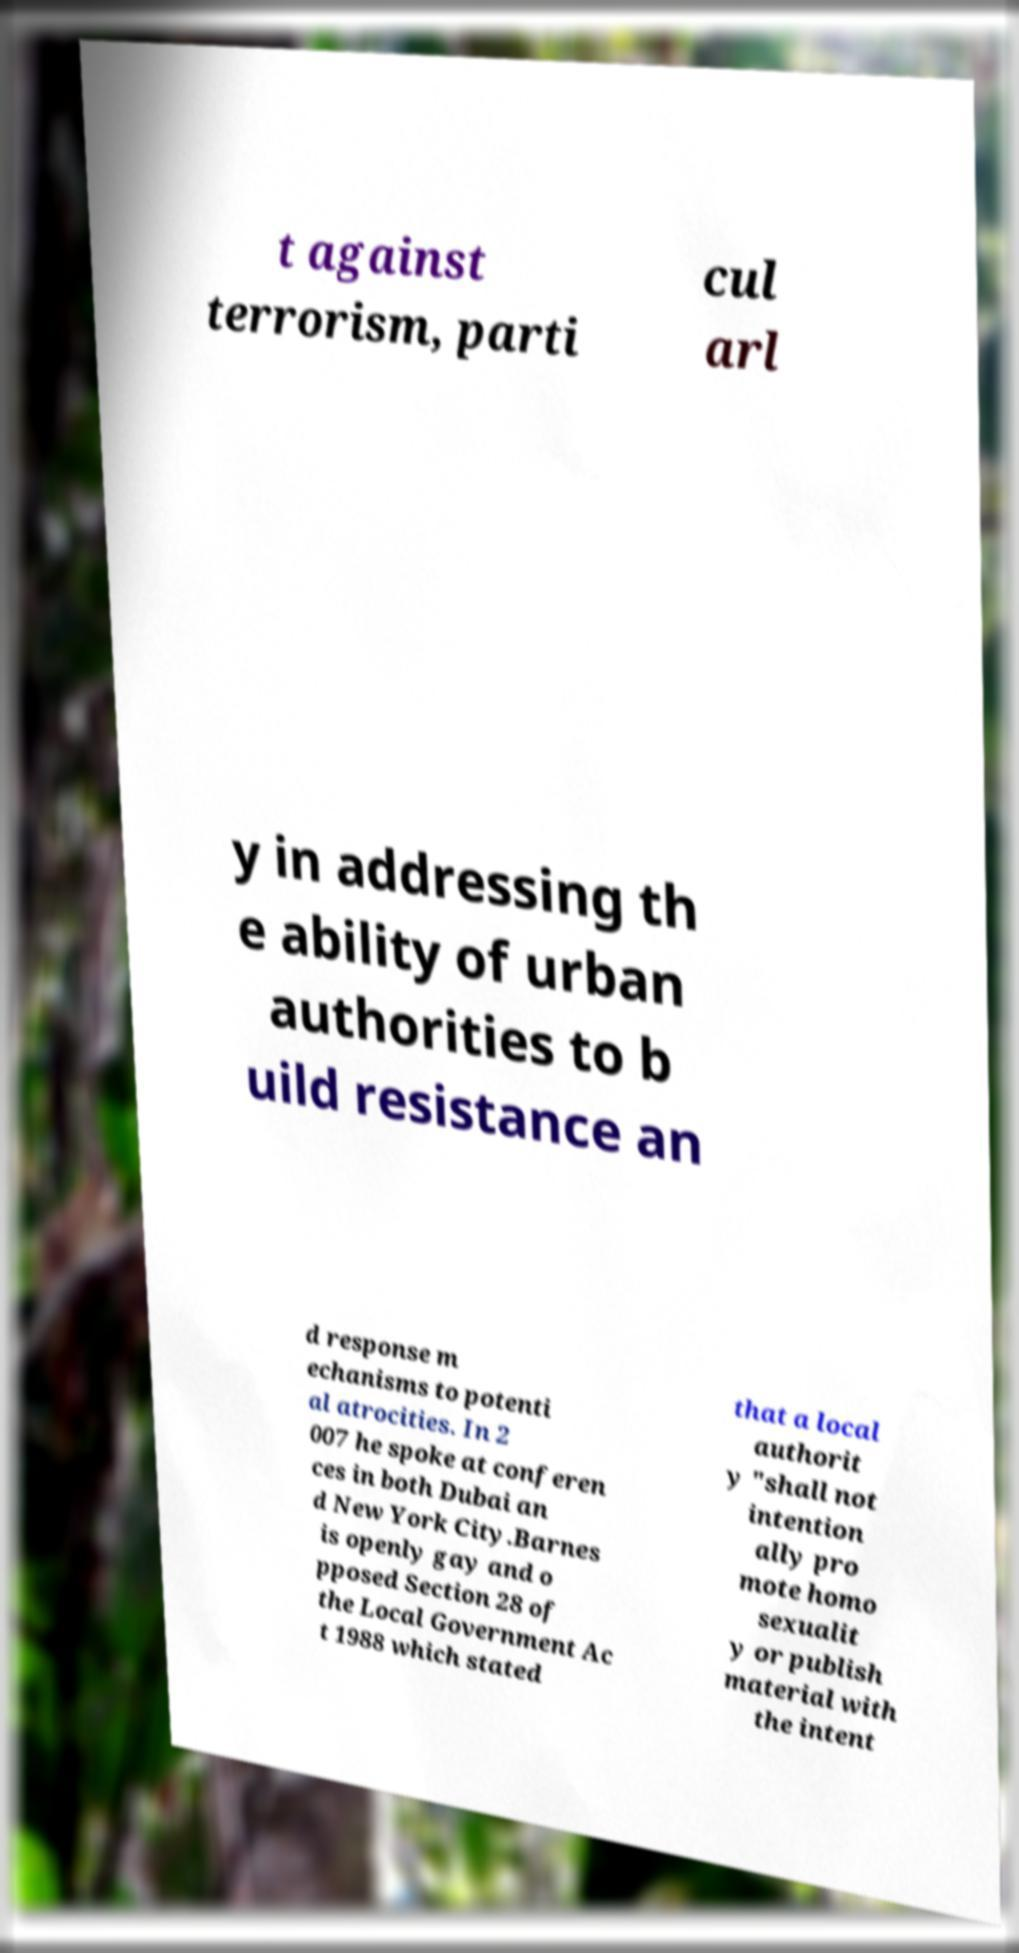What messages or text are displayed in this image? I need them in a readable, typed format. t against terrorism, parti cul arl y in addressing th e ability of urban authorities to b uild resistance an d response m echanisms to potenti al atrocities. In 2 007 he spoke at conferen ces in both Dubai an d New York City.Barnes is openly gay and o pposed Section 28 of the Local Government Ac t 1988 which stated that a local authorit y "shall not intention ally pro mote homo sexualit y or publish material with the intent 